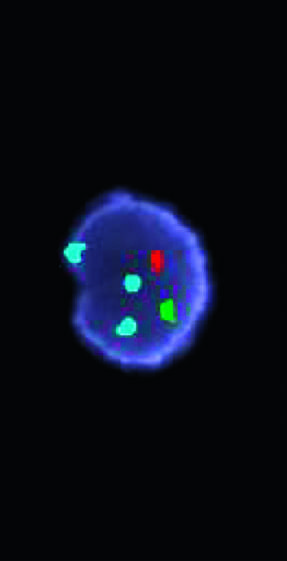what have been used in a fish cocktail?
Answer the question using a single word or phrase. Three different fluorescent probes 